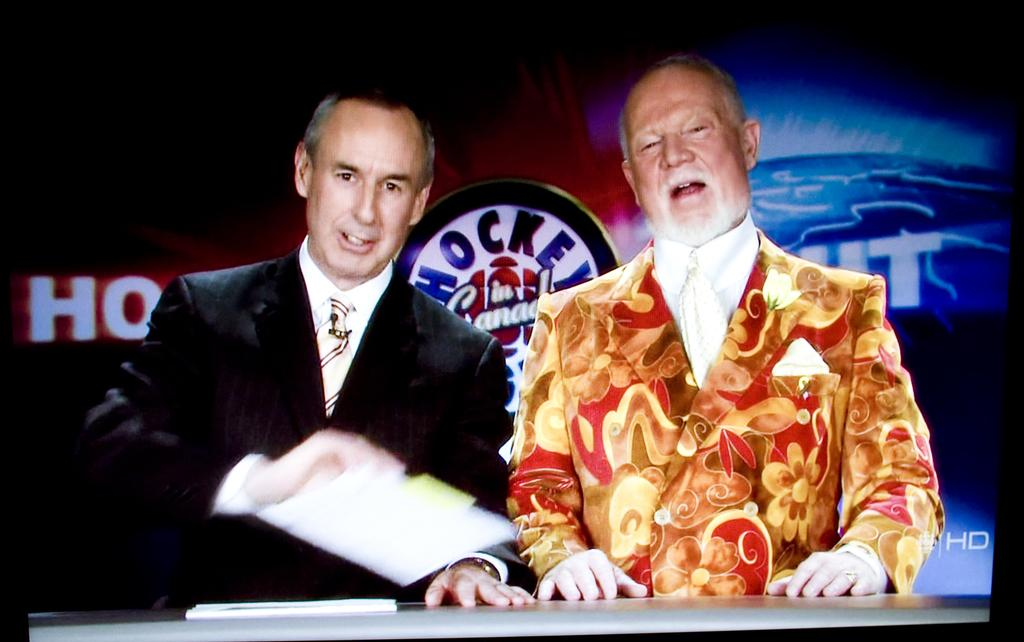How many men are in the image? There are two men in the image. What are the men wearing? Both men are wearing blazers and ties. What are the men doing in the image? The men are talking to each other. What is on the table in front of the men? There are papers on the table in front of them. What can be seen in the background of the image? There is a banner visible in the background of the image. Can you see a rabbit hopping around in the image? There is no rabbit present in the image. 